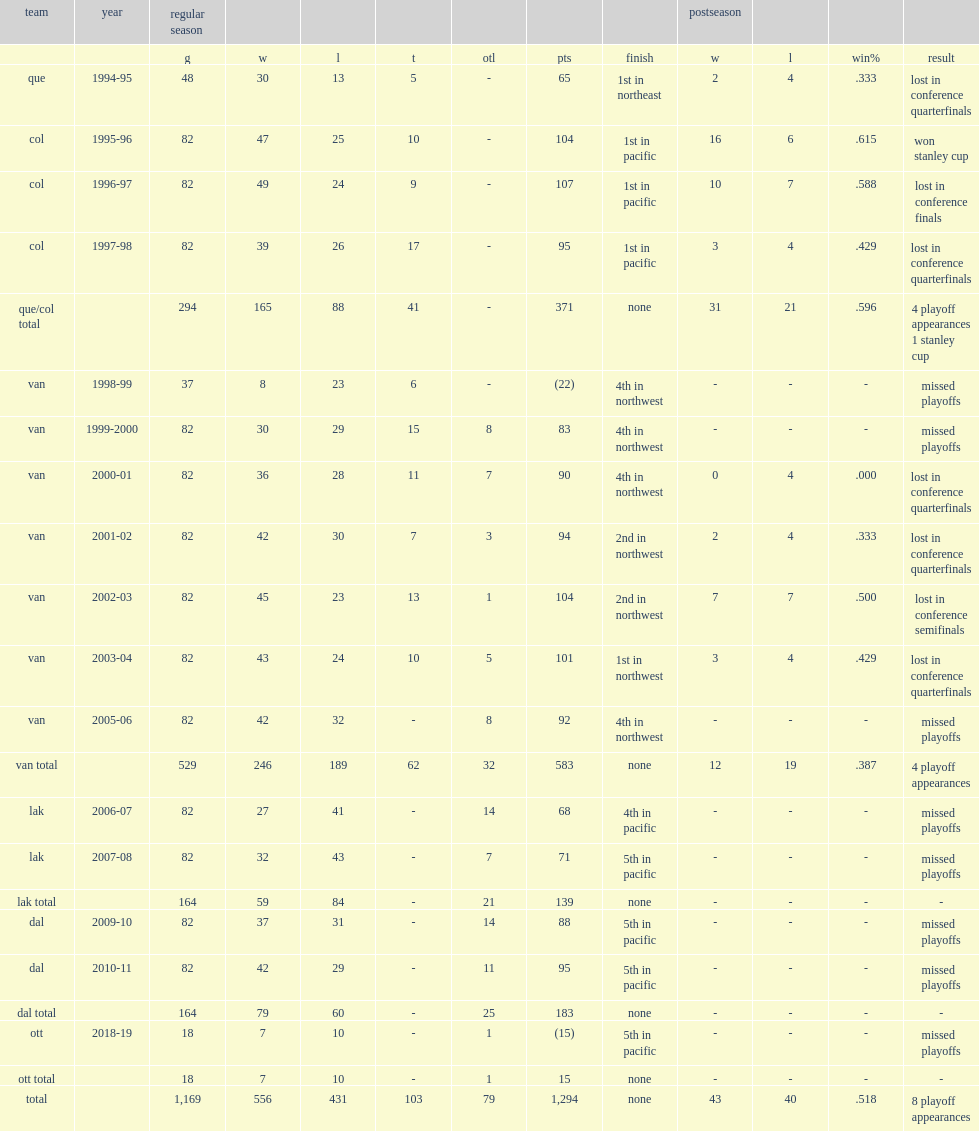How many games did crawford coach the canucks totally? 529.0. 